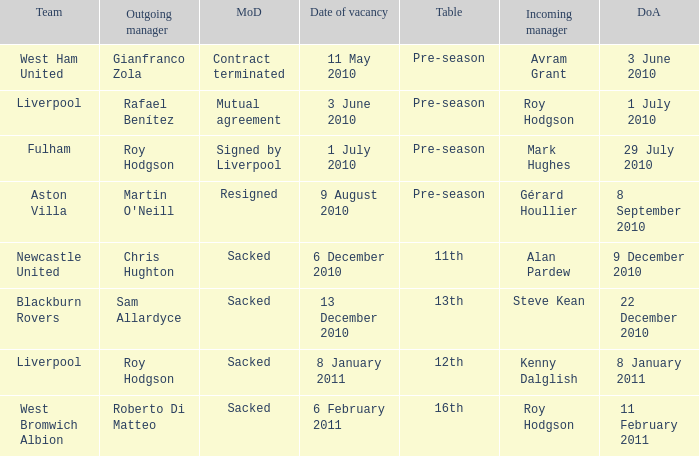Help me parse the entirety of this table. {'header': ['Team', 'Outgoing manager', 'MoD', 'Date of vacancy', 'Table', 'Incoming manager', 'DoA'], 'rows': [['West Ham United', 'Gianfranco Zola', 'Contract terminated', '11 May 2010', 'Pre-season', 'Avram Grant', '3 June 2010'], ['Liverpool', 'Rafael Benítez', 'Mutual agreement', '3 June 2010', 'Pre-season', 'Roy Hodgson', '1 July 2010'], ['Fulham', 'Roy Hodgson', 'Signed by Liverpool', '1 July 2010', 'Pre-season', 'Mark Hughes', '29 July 2010'], ['Aston Villa', "Martin O'Neill", 'Resigned', '9 August 2010', 'Pre-season', 'Gérard Houllier', '8 September 2010'], ['Newcastle United', 'Chris Hughton', 'Sacked', '6 December 2010', '11th', 'Alan Pardew', '9 December 2010'], ['Blackburn Rovers', 'Sam Allardyce', 'Sacked', '13 December 2010', '13th', 'Steve Kean', '22 December 2010'], ['Liverpool', 'Roy Hodgson', 'Sacked', '8 January 2011', '12th', 'Kenny Dalglish', '8 January 2011'], ['West Bromwich Albion', 'Roberto Di Matteo', 'Sacked', '6 February 2011', '16th', 'Roy Hodgson', '11 February 2011']]} What is the date of vacancy for the Liverpool team with a table named pre-season? 3 June 2010. 